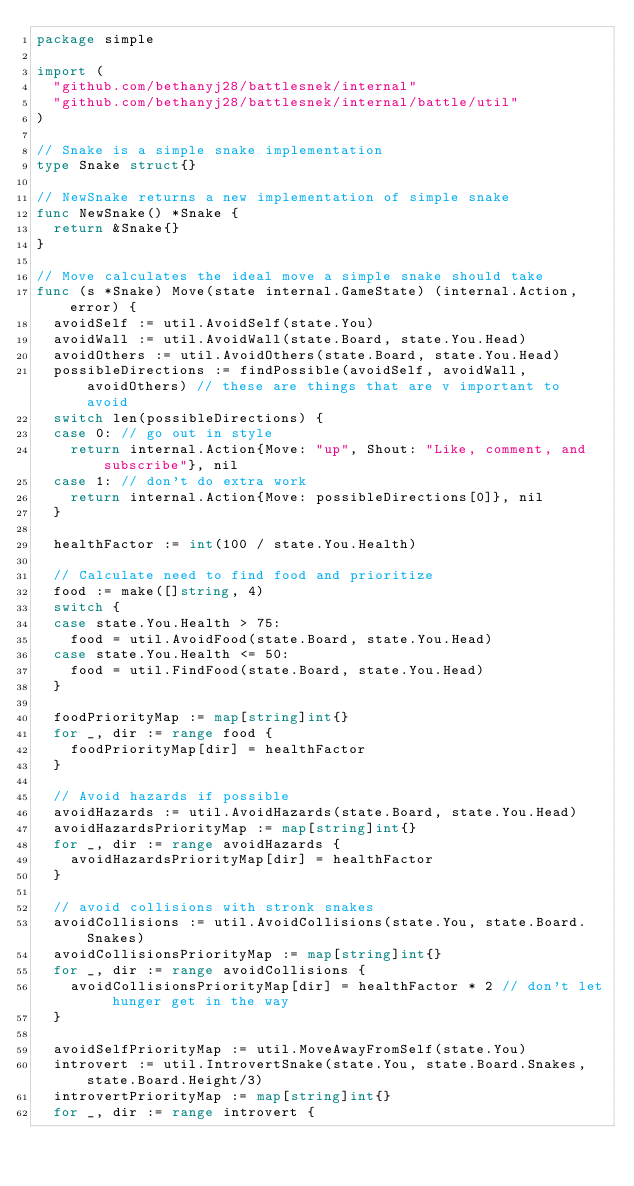Convert code to text. <code><loc_0><loc_0><loc_500><loc_500><_Go_>package simple

import (
	"github.com/bethanyj28/battlesnek/internal"
	"github.com/bethanyj28/battlesnek/internal/battle/util"
)

// Snake is a simple snake implementation
type Snake struct{}

// NewSnake returns a new implementation of simple snake
func NewSnake() *Snake {
	return &Snake{}
}

// Move calculates the ideal move a simple snake should take
func (s *Snake) Move(state internal.GameState) (internal.Action, error) {
	avoidSelf := util.AvoidSelf(state.You)
	avoidWall := util.AvoidWall(state.Board, state.You.Head)
	avoidOthers := util.AvoidOthers(state.Board, state.You.Head)
	possibleDirections := findPossible(avoidSelf, avoidWall, avoidOthers) // these are things that are v important to avoid
	switch len(possibleDirections) {
	case 0: // go out in style
		return internal.Action{Move: "up", Shout: "Like, comment, and subscribe"}, nil
	case 1: // don't do extra work
		return internal.Action{Move: possibleDirections[0]}, nil
	}

	healthFactor := int(100 / state.You.Health)

	// Calculate need to find food and prioritize
	food := make([]string, 4)
	switch {
	case state.You.Health > 75:
		food = util.AvoidFood(state.Board, state.You.Head)
	case state.You.Health <= 50:
		food = util.FindFood(state.Board, state.You.Head)
	}

	foodPriorityMap := map[string]int{}
	for _, dir := range food {
		foodPriorityMap[dir] = healthFactor
	}

	// Avoid hazards if possible
	avoidHazards := util.AvoidHazards(state.Board, state.You.Head)
	avoidHazardsPriorityMap := map[string]int{}
	for _, dir := range avoidHazards {
		avoidHazardsPriorityMap[dir] = healthFactor
	}

	// avoid collisions with stronk snakes
	avoidCollisions := util.AvoidCollisions(state.You, state.Board.Snakes)
	avoidCollisionsPriorityMap := map[string]int{}
	for _, dir := range avoidCollisions {
		avoidCollisionsPriorityMap[dir] = healthFactor * 2 // don't let hunger get in the way
	}

	avoidSelfPriorityMap := util.MoveAwayFromSelf(state.You)
	introvert := util.IntrovertSnake(state.You, state.Board.Snakes, state.Board.Height/3)
	introvertPriorityMap := map[string]int{}
	for _, dir := range introvert {</code> 